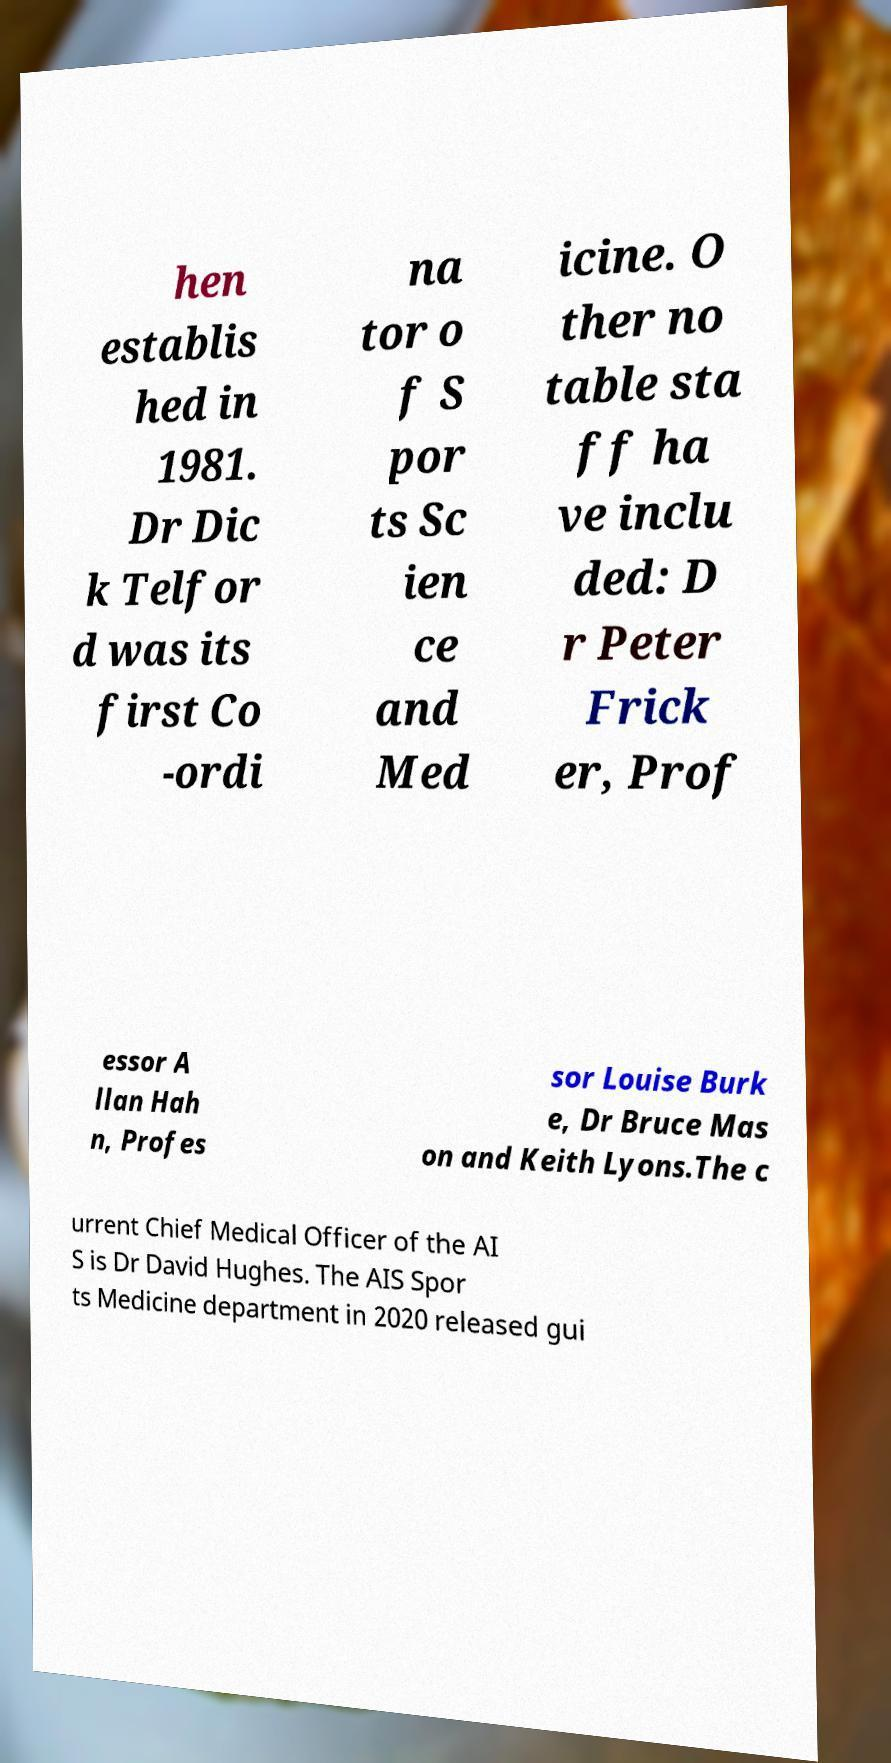Please read and relay the text visible in this image. What does it say? hen establis hed in 1981. Dr Dic k Telfor d was its first Co -ordi na tor o f S por ts Sc ien ce and Med icine. O ther no table sta ff ha ve inclu ded: D r Peter Frick er, Prof essor A llan Hah n, Profes sor Louise Burk e, Dr Bruce Mas on and Keith Lyons.The c urrent Chief Medical Officer of the AI S is Dr David Hughes. The AIS Spor ts Medicine department in 2020 released gui 